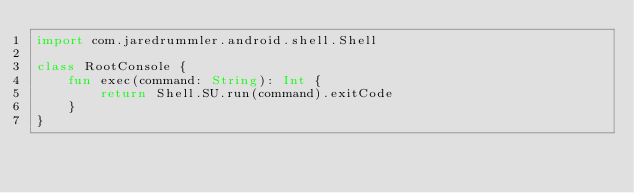Convert code to text. <code><loc_0><loc_0><loc_500><loc_500><_Kotlin_>import com.jaredrummler.android.shell.Shell

class RootConsole {
    fun exec(command: String): Int {
        return Shell.SU.run(command).exitCode
    }
}
</code> 